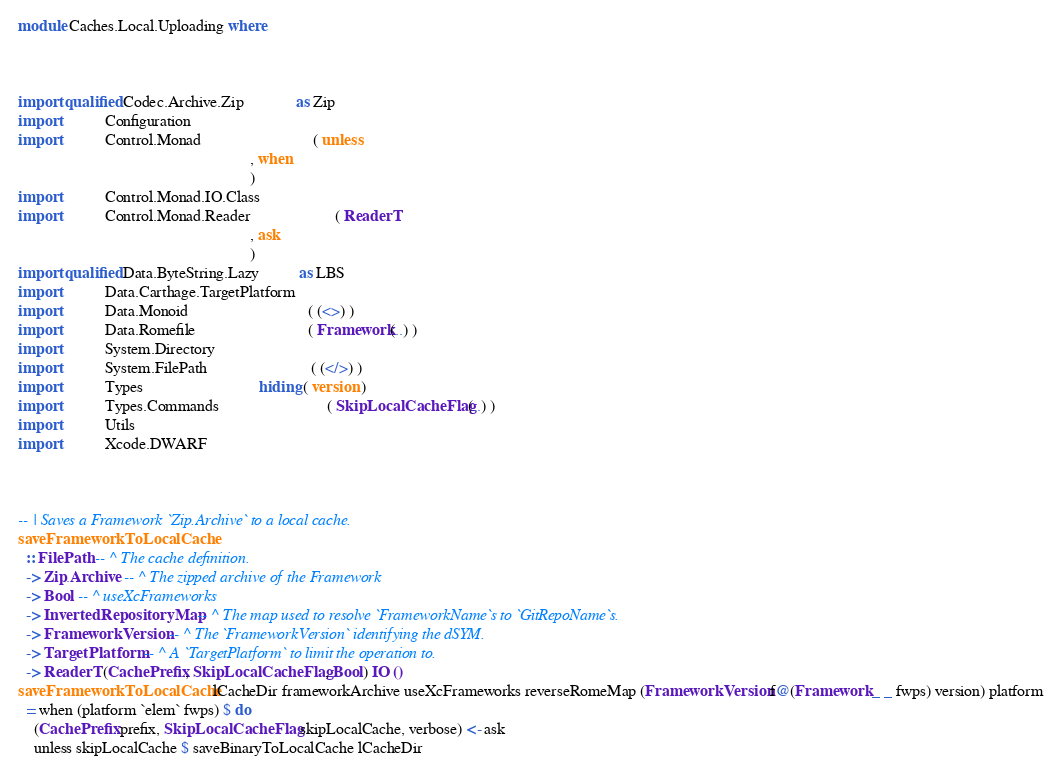Convert code to text. <code><loc_0><loc_0><loc_500><loc_500><_Haskell_>module Caches.Local.Uploading where



import qualified Codec.Archive.Zip             as Zip
import           Configuration
import           Control.Monad                            ( unless
                                                          , when
                                                          )
import           Control.Monad.IO.Class
import           Control.Monad.Reader                     ( ReaderT
                                                          , ask
                                                          )
import qualified Data.ByteString.Lazy          as LBS
import           Data.Carthage.TargetPlatform
import           Data.Monoid                              ( (<>) )
import           Data.Romefile                            ( Framework(..) )
import           System.Directory
import           System.FilePath                          ( (</>) )
import           Types                             hiding ( version )
import           Types.Commands                           ( SkipLocalCacheFlag(..) )
import           Utils
import           Xcode.DWARF



-- | Saves a Framework `Zip.Archive` to a local cache.
saveFrameworkToLocalCache
  :: FilePath -- ^ The cache definition.
  -> Zip.Archive -- ^ The zipped archive of the Framework
  -> Bool -- ^ useXcFrameworks
  -> InvertedRepositoryMap -- ^ The map used to resolve `FrameworkName`s to `GitRepoName`s.
  -> FrameworkVersion -- ^ The `FrameworkVersion` identifying the dSYM.
  -> TargetPlatform -- ^ A `TargetPlatform` to limit the operation to.
  -> ReaderT (CachePrefix, SkipLocalCacheFlag, Bool) IO ()
saveFrameworkToLocalCache lCacheDir frameworkArchive useXcFrameworks reverseRomeMap (FrameworkVersion f@(Framework _ _ fwps) version) platform
  = when (platform `elem` fwps) $ do
    (CachePrefix prefix, SkipLocalCacheFlag skipLocalCache, verbose) <- ask
    unless skipLocalCache $ saveBinaryToLocalCache lCacheDir</code> 